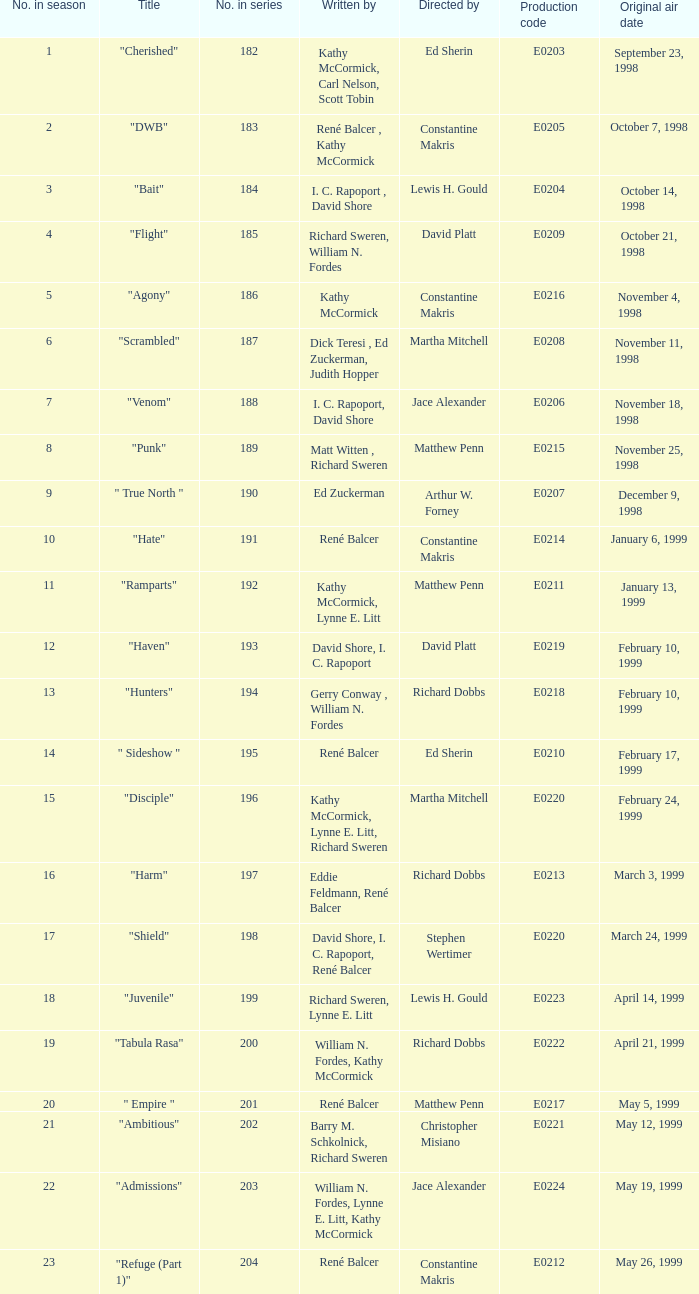The episode with the title "Bait" has what original air date? October 14, 1998. 